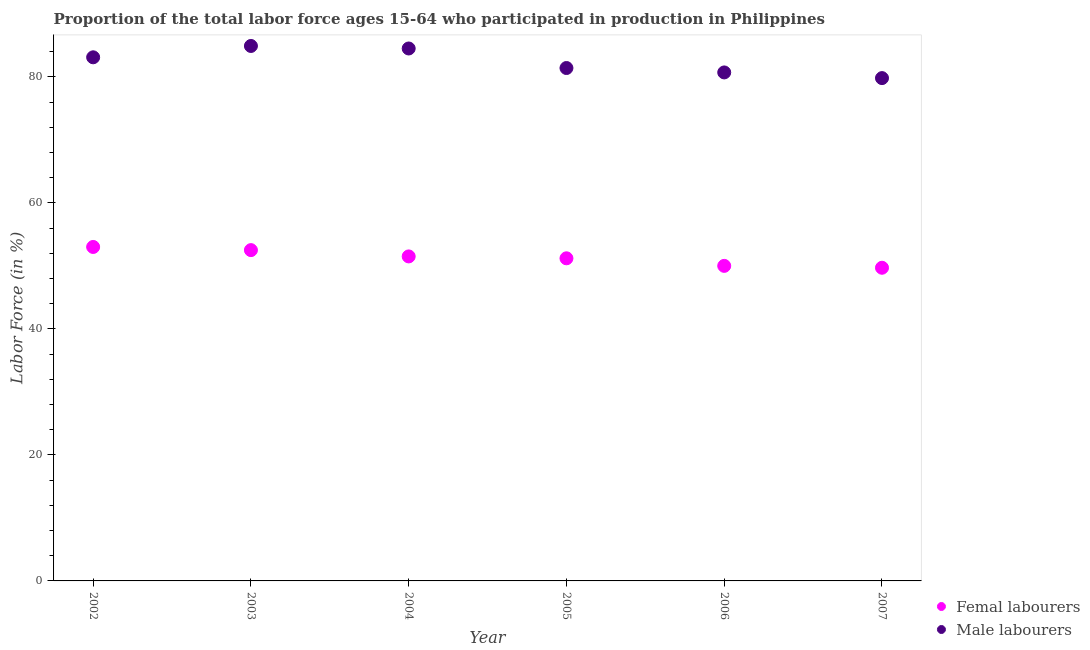Is the number of dotlines equal to the number of legend labels?
Your answer should be very brief. Yes. What is the percentage of female labor force in 2003?
Make the answer very short. 52.5. Across all years, what is the minimum percentage of female labor force?
Offer a terse response. 49.7. In which year was the percentage of female labor force maximum?
Provide a succinct answer. 2002. What is the total percentage of male labour force in the graph?
Give a very brief answer. 494.4. What is the difference between the percentage of male labour force in 2007 and the percentage of female labor force in 2004?
Your response must be concise. 28.3. What is the average percentage of male labour force per year?
Offer a terse response. 82.4. In the year 2007, what is the difference between the percentage of male labour force and percentage of female labor force?
Offer a very short reply. 30.1. In how many years, is the percentage of female labor force greater than 20 %?
Your answer should be compact. 6. What is the ratio of the percentage of female labor force in 2004 to that in 2007?
Give a very brief answer. 1.04. What is the difference between the highest and the second highest percentage of male labour force?
Your answer should be compact. 0.4. What is the difference between the highest and the lowest percentage of male labour force?
Give a very brief answer. 5.1. Is the percentage of female labor force strictly greater than the percentage of male labour force over the years?
Provide a short and direct response. No. How many dotlines are there?
Give a very brief answer. 2. How many years are there in the graph?
Give a very brief answer. 6. Are the values on the major ticks of Y-axis written in scientific E-notation?
Keep it short and to the point. No. Does the graph contain any zero values?
Your answer should be compact. No. Where does the legend appear in the graph?
Your response must be concise. Bottom right. How many legend labels are there?
Keep it short and to the point. 2. How are the legend labels stacked?
Provide a succinct answer. Vertical. What is the title of the graph?
Offer a very short reply. Proportion of the total labor force ages 15-64 who participated in production in Philippines. What is the label or title of the X-axis?
Your answer should be compact. Year. What is the label or title of the Y-axis?
Provide a short and direct response. Labor Force (in %). What is the Labor Force (in %) in Male labourers in 2002?
Make the answer very short. 83.1. What is the Labor Force (in %) of Femal labourers in 2003?
Keep it short and to the point. 52.5. What is the Labor Force (in %) in Male labourers in 2003?
Your answer should be very brief. 84.9. What is the Labor Force (in %) of Femal labourers in 2004?
Give a very brief answer. 51.5. What is the Labor Force (in %) in Male labourers in 2004?
Your answer should be very brief. 84.5. What is the Labor Force (in %) in Femal labourers in 2005?
Give a very brief answer. 51.2. What is the Labor Force (in %) in Male labourers in 2005?
Your answer should be very brief. 81.4. What is the Labor Force (in %) in Femal labourers in 2006?
Your answer should be compact. 50. What is the Labor Force (in %) of Male labourers in 2006?
Ensure brevity in your answer.  80.7. What is the Labor Force (in %) in Femal labourers in 2007?
Provide a short and direct response. 49.7. What is the Labor Force (in %) in Male labourers in 2007?
Your response must be concise. 79.8. Across all years, what is the maximum Labor Force (in %) of Femal labourers?
Your answer should be compact. 53. Across all years, what is the maximum Labor Force (in %) in Male labourers?
Your answer should be compact. 84.9. Across all years, what is the minimum Labor Force (in %) of Femal labourers?
Your answer should be very brief. 49.7. Across all years, what is the minimum Labor Force (in %) in Male labourers?
Offer a very short reply. 79.8. What is the total Labor Force (in %) of Femal labourers in the graph?
Your answer should be compact. 307.9. What is the total Labor Force (in %) in Male labourers in the graph?
Your answer should be very brief. 494.4. What is the difference between the Labor Force (in %) of Femal labourers in 2002 and that in 2003?
Give a very brief answer. 0.5. What is the difference between the Labor Force (in %) of Femal labourers in 2002 and that in 2004?
Give a very brief answer. 1.5. What is the difference between the Labor Force (in %) of Male labourers in 2002 and that in 2004?
Provide a succinct answer. -1.4. What is the difference between the Labor Force (in %) in Male labourers in 2002 and that in 2005?
Your answer should be very brief. 1.7. What is the difference between the Labor Force (in %) of Femal labourers in 2002 and that in 2006?
Offer a terse response. 3. What is the difference between the Labor Force (in %) in Male labourers in 2002 and that in 2006?
Provide a succinct answer. 2.4. What is the difference between the Labor Force (in %) of Femal labourers in 2003 and that in 2004?
Your answer should be very brief. 1. What is the difference between the Labor Force (in %) in Femal labourers in 2003 and that in 2005?
Ensure brevity in your answer.  1.3. What is the difference between the Labor Force (in %) in Male labourers in 2003 and that in 2005?
Your answer should be very brief. 3.5. What is the difference between the Labor Force (in %) of Male labourers in 2003 and that in 2006?
Ensure brevity in your answer.  4.2. What is the difference between the Labor Force (in %) in Male labourers in 2003 and that in 2007?
Offer a very short reply. 5.1. What is the difference between the Labor Force (in %) of Male labourers in 2004 and that in 2006?
Your response must be concise. 3.8. What is the difference between the Labor Force (in %) in Femal labourers in 2004 and that in 2007?
Your answer should be very brief. 1.8. What is the difference between the Labor Force (in %) of Femal labourers in 2005 and that in 2007?
Offer a very short reply. 1.5. What is the difference between the Labor Force (in %) in Male labourers in 2005 and that in 2007?
Give a very brief answer. 1.6. What is the difference between the Labor Force (in %) of Femal labourers in 2002 and the Labor Force (in %) of Male labourers in 2003?
Your answer should be very brief. -31.9. What is the difference between the Labor Force (in %) in Femal labourers in 2002 and the Labor Force (in %) in Male labourers in 2004?
Provide a succinct answer. -31.5. What is the difference between the Labor Force (in %) of Femal labourers in 2002 and the Labor Force (in %) of Male labourers in 2005?
Keep it short and to the point. -28.4. What is the difference between the Labor Force (in %) in Femal labourers in 2002 and the Labor Force (in %) in Male labourers in 2006?
Provide a succinct answer. -27.7. What is the difference between the Labor Force (in %) in Femal labourers in 2002 and the Labor Force (in %) in Male labourers in 2007?
Ensure brevity in your answer.  -26.8. What is the difference between the Labor Force (in %) in Femal labourers in 2003 and the Labor Force (in %) in Male labourers in 2004?
Ensure brevity in your answer.  -32. What is the difference between the Labor Force (in %) of Femal labourers in 2003 and the Labor Force (in %) of Male labourers in 2005?
Your answer should be compact. -28.9. What is the difference between the Labor Force (in %) in Femal labourers in 2003 and the Labor Force (in %) in Male labourers in 2006?
Provide a short and direct response. -28.2. What is the difference between the Labor Force (in %) of Femal labourers in 2003 and the Labor Force (in %) of Male labourers in 2007?
Offer a terse response. -27.3. What is the difference between the Labor Force (in %) of Femal labourers in 2004 and the Labor Force (in %) of Male labourers in 2005?
Make the answer very short. -29.9. What is the difference between the Labor Force (in %) in Femal labourers in 2004 and the Labor Force (in %) in Male labourers in 2006?
Ensure brevity in your answer.  -29.2. What is the difference between the Labor Force (in %) of Femal labourers in 2004 and the Labor Force (in %) of Male labourers in 2007?
Your answer should be compact. -28.3. What is the difference between the Labor Force (in %) of Femal labourers in 2005 and the Labor Force (in %) of Male labourers in 2006?
Your answer should be very brief. -29.5. What is the difference between the Labor Force (in %) of Femal labourers in 2005 and the Labor Force (in %) of Male labourers in 2007?
Provide a succinct answer. -28.6. What is the difference between the Labor Force (in %) in Femal labourers in 2006 and the Labor Force (in %) in Male labourers in 2007?
Offer a very short reply. -29.8. What is the average Labor Force (in %) in Femal labourers per year?
Provide a short and direct response. 51.32. What is the average Labor Force (in %) in Male labourers per year?
Offer a terse response. 82.4. In the year 2002, what is the difference between the Labor Force (in %) of Femal labourers and Labor Force (in %) of Male labourers?
Your response must be concise. -30.1. In the year 2003, what is the difference between the Labor Force (in %) in Femal labourers and Labor Force (in %) in Male labourers?
Your answer should be compact. -32.4. In the year 2004, what is the difference between the Labor Force (in %) of Femal labourers and Labor Force (in %) of Male labourers?
Give a very brief answer. -33. In the year 2005, what is the difference between the Labor Force (in %) of Femal labourers and Labor Force (in %) of Male labourers?
Offer a terse response. -30.2. In the year 2006, what is the difference between the Labor Force (in %) in Femal labourers and Labor Force (in %) in Male labourers?
Your answer should be compact. -30.7. In the year 2007, what is the difference between the Labor Force (in %) of Femal labourers and Labor Force (in %) of Male labourers?
Offer a terse response. -30.1. What is the ratio of the Labor Force (in %) of Femal labourers in 2002 to that in 2003?
Make the answer very short. 1.01. What is the ratio of the Labor Force (in %) in Male labourers in 2002 to that in 2003?
Make the answer very short. 0.98. What is the ratio of the Labor Force (in %) of Femal labourers in 2002 to that in 2004?
Keep it short and to the point. 1.03. What is the ratio of the Labor Force (in %) in Male labourers in 2002 to that in 2004?
Ensure brevity in your answer.  0.98. What is the ratio of the Labor Force (in %) of Femal labourers in 2002 to that in 2005?
Give a very brief answer. 1.04. What is the ratio of the Labor Force (in %) in Male labourers in 2002 to that in 2005?
Provide a short and direct response. 1.02. What is the ratio of the Labor Force (in %) of Femal labourers in 2002 to that in 2006?
Provide a short and direct response. 1.06. What is the ratio of the Labor Force (in %) of Male labourers in 2002 to that in 2006?
Give a very brief answer. 1.03. What is the ratio of the Labor Force (in %) of Femal labourers in 2002 to that in 2007?
Keep it short and to the point. 1.07. What is the ratio of the Labor Force (in %) in Male labourers in 2002 to that in 2007?
Ensure brevity in your answer.  1.04. What is the ratio of the Labor Force (in %) in Femal labourers in 2003 to that in 2004?
Keep it short and to the point. 1.02. What is the ratio of the Labor Force (in %) in Femal labourers in 2003 to that in 2005?
Keep it short and to the point. 1.03. What is the ratio of the Labor Force (in %) in Male labourers in 2003 to that in 2005?
Ensure brevity in your answer.  1.04. What is the ratio of the Labor Force (in %) of Femal labourers in 2003 to that in 2006?
Keep it short and to the point. 1.05. What is the ratio of the Labor Force (in %) of Male labourers in 2003 to that in 2006?
Ensure brevity in your answer.  1.05. What is the ratio of the Labor Force (in %) of Femal labourers in 2003 to that in 2007?
Give a very brief answer. 1.06. What is the ratio of the Labor Force (in %) of Male labourers in 2003 to that in 2007?
Provide a succinct answer. 1.06. What is the ratio of the Labor Force (in %) of Femal labourers in 2004 to that in 2005?
Provide a short and direct response. 1.01. What is the ratio of the Labor Force (in %) of Male labourers in 2004 to that in 2005?
Provide a succinct answer. 1.04. What is the ratio of the Labor Force (in %) of Male labourers in 2004 to that in 2006?
Ensure brevity in your answer.  1.05. What is the ratio of the Labor Force (in %) of Femal labourers in 2004 to that in 2007?
Offer a terse response. 1.04. What is the ratio of the Labor Force (in %) of Male labourers in 2004 to that in 2007?
Provide a short and direct response. 1.06. What is the ratio of the Labor Force (in %) in Femal labourers in 2005 to that in 2006?
Your answer should be compact. 1.02. What is the ratio of the Labor Force (in %) of Male labourers in 2005 to that in 2006?
Provide a succinct answer. 1.01. What is the ratio of the Labor Force (in %) of Femal labourers in 2005 to that in 2007?
Offer a very short reply. 1.03. What is the ratio of the Labor Force (in %) of Male labourers in 2005 to that in 2007?
Provide a succinct answer. 1.02. What is the ratio of the Labor Force (in %) of Male labourers in 2006 to that in 2007?
Keep it short and to the point. 1.01. What is the difference between the highest and the second highest Labor Force (in %) of Male labourers?
Make the answer very short. 0.4. What is the difference between the highest and the lowest Labor Force (in %) of Femal labourers?
Offer a very short reply. 3.3. 